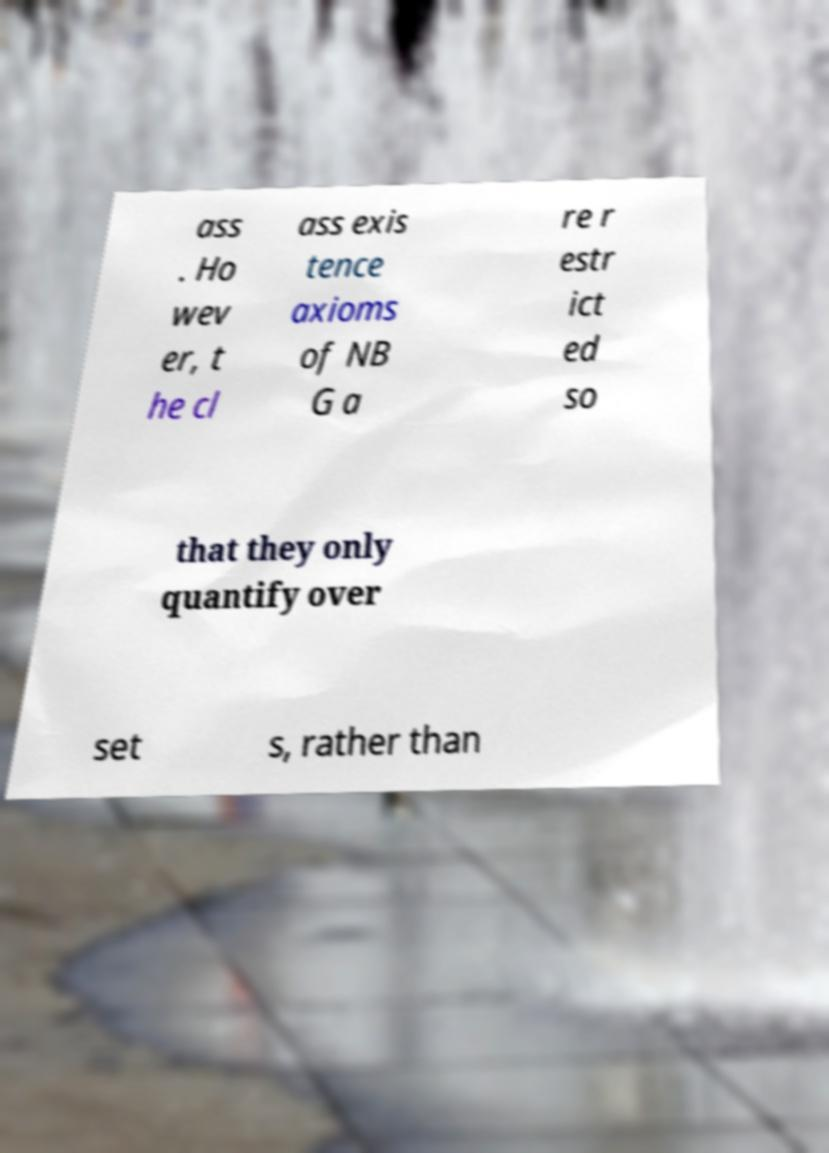There's text embedded in this image that I need extracted. Can you transcribe it verbatim? ass . Ho wev er, t he cl ass exis tence axioms of NB G a re r estr ict ed so that they only quantify over set s, rather than 